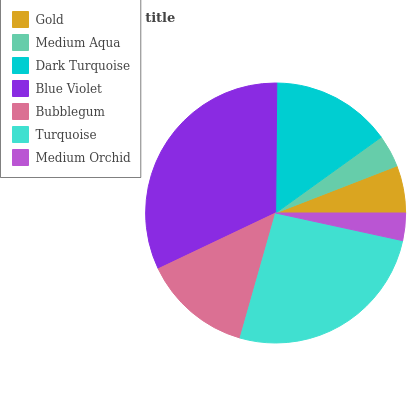Is Medium Orchid the minimum?
Answer yes or no. Yes. Is Blue Violet the maximum?
Answer yes or no. Yes. Is Medium Aqua the minimum?
Answer yes or no. No. Is Medium Aqua the maximum?
Answer yes or no. No. Is Gold greater than Medium Aqua?
Answer yes or no. Yes. Is Medium Aqua less than Gold?
Answer yes or no. Yes. Is Medium Aqua greater than Gold?
Answer yes or no. No. Is Gold less than Medium Aqua?
Answer yes or no. No. Is Bubblegum the high median?
Answer yes or no. Yes. Is Bubblegum the low median?
Answer yes or no. Yes. Is Gold the high median?
Answer yes or no. No. Is Dark Turquoise the low median?
Answer yes or no. No. 